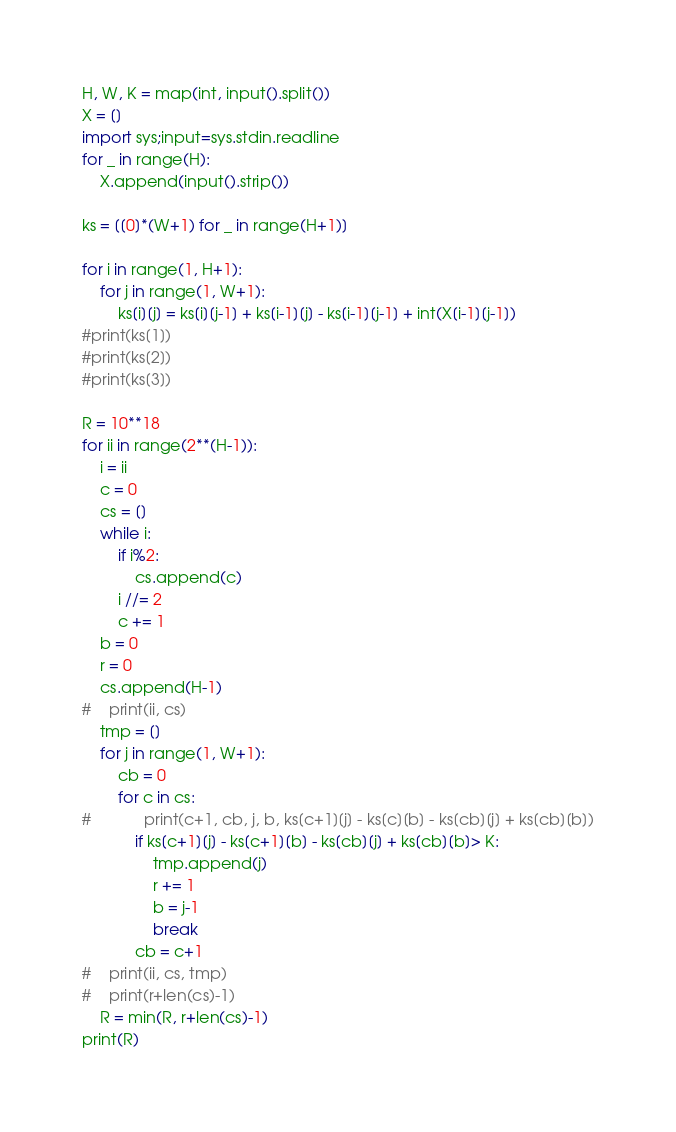Convert code to text. <code><loc_0><loc_0><loc_500><loc_500><_Python_>H, W, K = map(int, input().split())
X = []
import sys;input=sys.stdin.readline
for _ in range(H):
    X.append(input().strip())

ks = [[0]*(W+1) for _ in range(H+1)]

for i in range(1, H+1):
    for j in range(1, W+1):
        ks[i][j] = ks[i][j-1] + ks[i-1][j] - ks[i-1][j-1] + int(X[i-1][j-1])
#print(ks[1])
#print(ks[2])
#print(ks[3])

R = 10**18
for ii in range(2**(H-1)):
    i = ii
    c = 0
    cs = []
    while i:
        if i%2:
            cs.append(c)
        i //= 2
        c += 1
    b = 0
    r = 0
    cs.append(H-1)
#    print(ii, cs)
    tmp = []
    for j in range(1, W+1):
        cb = 0
        for c in cs:
#            print(c+1, cb, j, b, ks[c+1][j] - ks[c][b] - ks[cb][j] + ks[cb][b])
            if ks[c+1][j] - ks[c+1][b] - ks[cb][j] + ks[cb][b]> K:
                tmp.append(j)
                r += 1
                b = j-1
                break
            cb = c+1
#    print(ii, cs, tmp)
#    print(r+len(cs)-1)
    R = min(R, r+len(cs)-1)
print(R)
</code> 